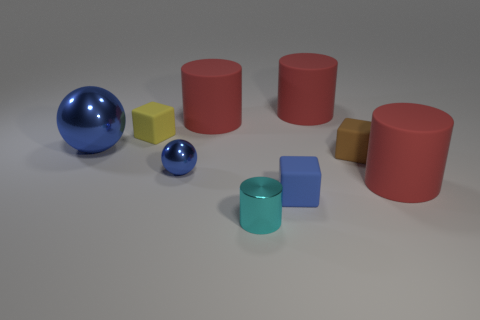Are there fewer small yellow objects behind the cyan cylinder than blue rubber blocks on the right side of the small blue cube?
Your response must be concise. No. There is a tiny blue thing that is made of the same material as the large ball; what shape is it?
Make the answer very short. Sphere. How big is the blue object that is to the right of the tiny shiny object that is in front of the object that is right of the tiny brown object?
Make the answer very short. Small. Is the number of cyan things greater than the number of large cyan balls?
Your answer should be compact. Yes. Do the matte cylinder to the right of the small brown rubber object and the cylinder on the left side of the small cyan shiny cylinder have the same color?
Give a very brief answer. Yes. Does the big red cylinder that is left of the blue cube have the same material as the small thing in front of the blue block?
Ensure brevity in your answer.  No. How many yellow matte blocks are the same size as the blue rubber cube?
Provide a short and direct response. 1. Is the number of objects less than the number of blue spheres?
Your answer should be very brief. No. The small rubber thing behind the blue metal sphere behind the small blue metallic object is what shape?
Ensure brevity in your answer.  Cube. The cyan metallic thing that is the same size as the blue rubber cube is what shape?
Give a very brief answer. Cylinder. 